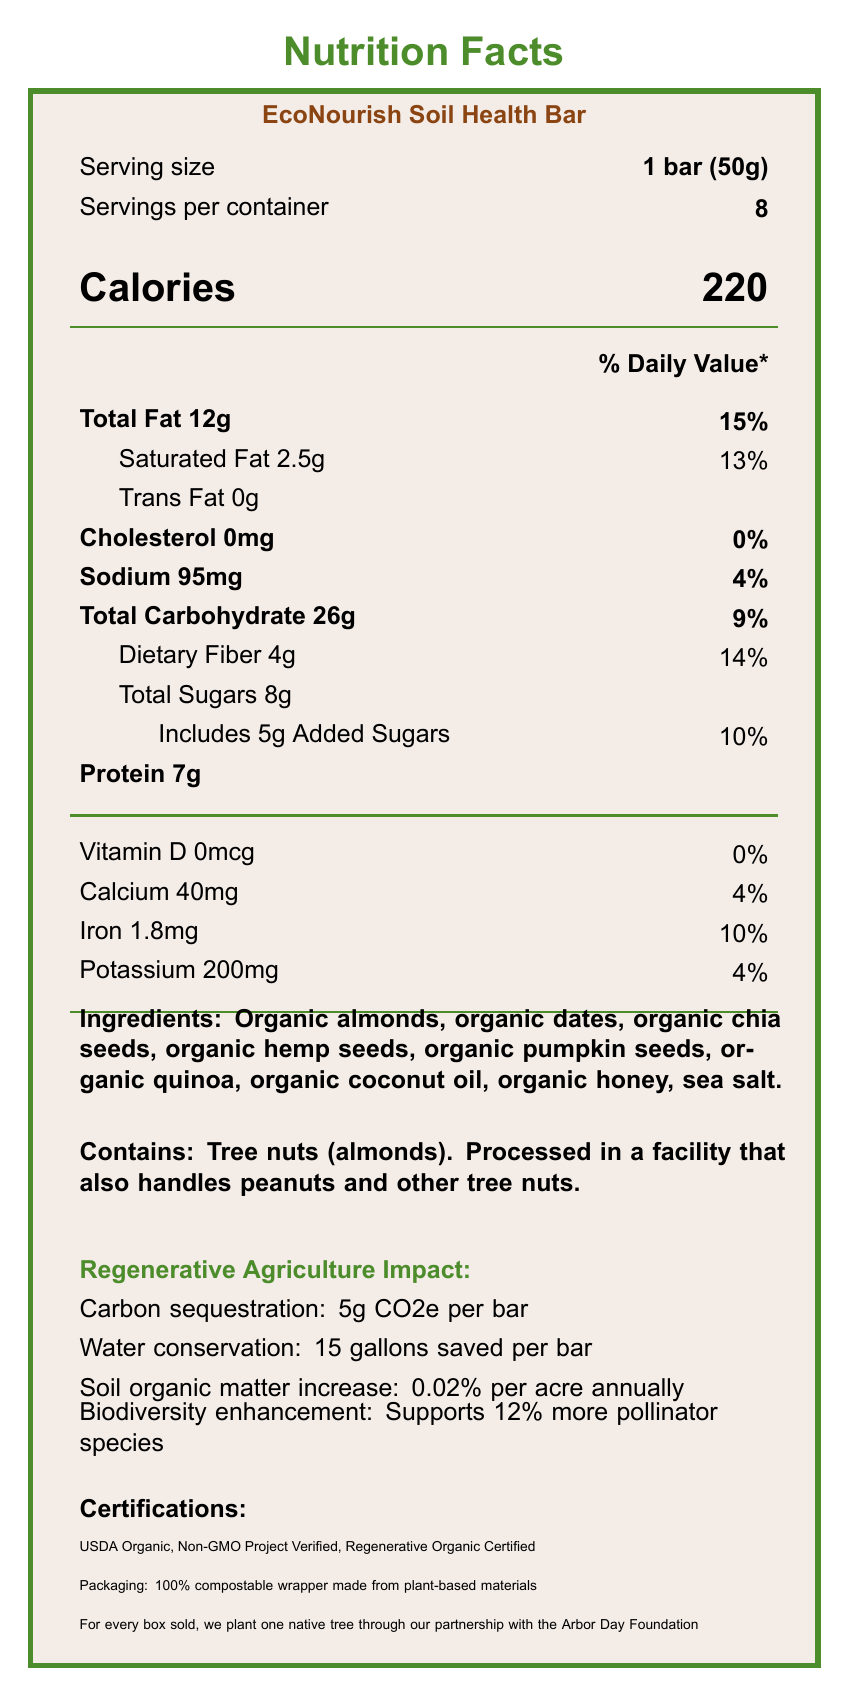what is the serving size of the EcoNourish Soil Health Bar? The serving size is explicitly stated as "1 bar (50g)" in the document.
Answer: 1 bar (50g) how many calories are in one serving of the bar? The calories per serving are listed as 220.
Answer: 220 what percentage of the daily value does the total fat content represent? The total fat content represents 15% of the daily value.
Answer: 15% how much dietary fiber is in each serving? The dietary fiber in each serving is 4g.
Answer: 4g how many more grams of added sugars are there compared to trans fats? The added sugars amount is 5g, and the trans fats amount is 0g. Thus, there are 5g more added sugars compared to trans fats.
Answer: 5g what vitamins and minerals are specifically listed, and what are the daily values for each? The listed vitamins and minerals and their daily values are: Vitamin D 0%, Calcium 4%, Iron 10%, and Potassium 4%.
Answer: Vitamin D 0%, Calcium 4%, Iron 10%, Potassium 4% which certification is not listed for the EcoNourish Soil Health Bar? A. USDA Organic B. Non-GMO Project Verified C. Fair Trade Certified D. Regenerative Organic Certified The listed certifications are USDA Organic, Non-GMO Project Verified, and Regenerative Organic Certified. Fair Trade Certified is not listed.
Answer: C how much water is conserved per bar according to the regenerative agriculture information? A. 10 gallons B. 15 gallons C. 20 gallons D. 25 gallons The document states that 15 gallons are saved per bar.
Answer: B does the EcoNourish Soil Health Bar contain peanuts? The document states that the bar contains tree nuts (almonds), but is processed in a facility that also handles peanuts.
Answer: No summarize the main environmental benefits of the EcoNourish Soil Health Bar The main environmental benefits are effectively described in a section beneath the nutritional information. Other supporting details about sustainability commitments and certifications are also highlighted in the same area.
Answer: The EcoNourish Soil Health Bar offers environmental benefits such as carbon sequestration (5g CO2e per bar), water conservation (15 gallons saved per bar), soil organic matter increase (0.02% per acre annually), and supports 12% more pollinator species. In addition, the bar is made with organic ingredients and aims for sustainability through 100% compostable packaging and a commitment to planting a native tree for every box sold. what is the impact on sodium intake if consuming two servings? Each serving contains 95mg sodium. Consuming two servings would double the sodium intake to 190mg.
Answer: 190mg identify one allergen present in the EcoNourish Soil Health Bar. The presence of tree nuts (almonds) is explicitly mentioned in the allergen section.
Answer: Tree nuts (almonds) what is the main ingredient in the EcoNourish Soil Health Bar? The first ingredient listed is typically the main ingredient, and in this case, it is organic almonds.
Answer: Organic almonds what is the most prominent visual feature of the label? The title "Nutrition Facts" is prominently displayed at the top in bold, large font.
Answer: The title "Nutrition Facts" how much iron is in one serving of the bar, and how does that translate to the daily value percentage? One serving contains 1.8mg of iron, which is 10% of the daily value.
Answer: 1.8mg, 10% what are the environmental certifications of the EcoNourish Soil Health Bar? The certifications listed include USDA Organic, Non-GMO Project Verified, and Regenerative Organic Certified.
Answer: USDA Organic, Non-GMO Project Verified, Regenerative Organic Certified who is the individual behind creating the document? The creator of the document is not mentioned or identified in the visible information within the document.
Answer: Cannot be determined 